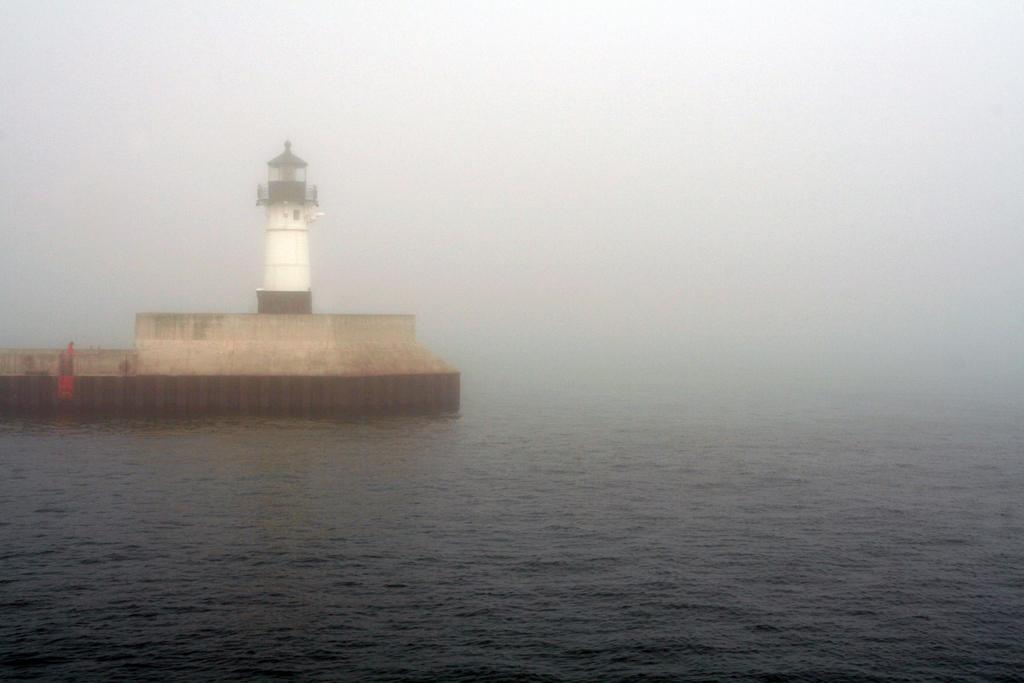What is the main structure in the image? There is a tower in the image. Where is the tower located? The tower is in the water. How many pipes can be seen connected to the tower in the image? There are no pipes visible in the image; it only shows a tower in the water. 